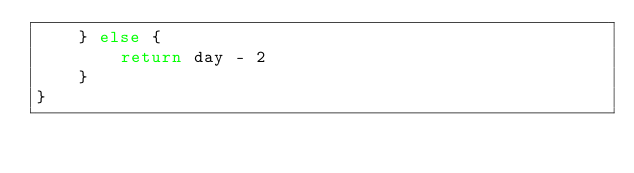Convert code to text. <code><loc_0><loc_0><loc_500><loc_500><_Kotlin_>    } else {
        return day - 2
    }
}</code> 